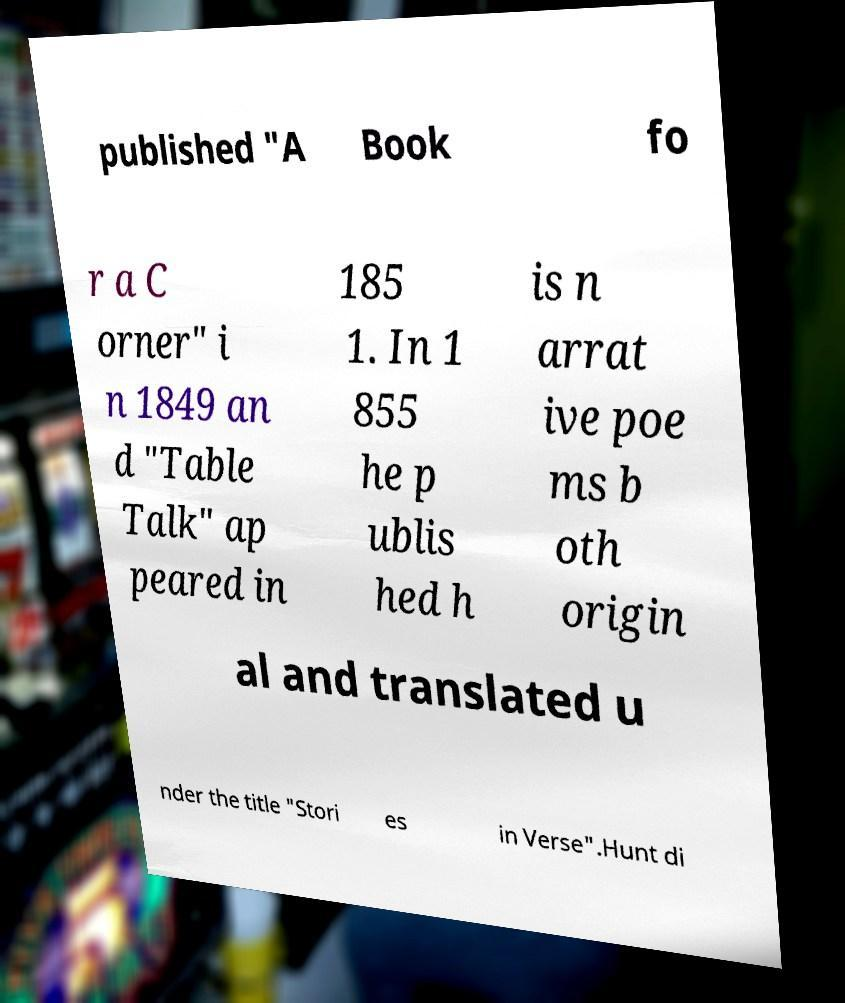What messages or text are displayed in this image? I need them in a readable, typed format. published "A Book fo r a C orner" i n 1849 an d "Table Talk" ap peared in 185 1. In 1 855 he p ublis hed h is n arrat ive poe ms b oth origin al and translated u nder the title "Stori es in Verse".Hunt di 